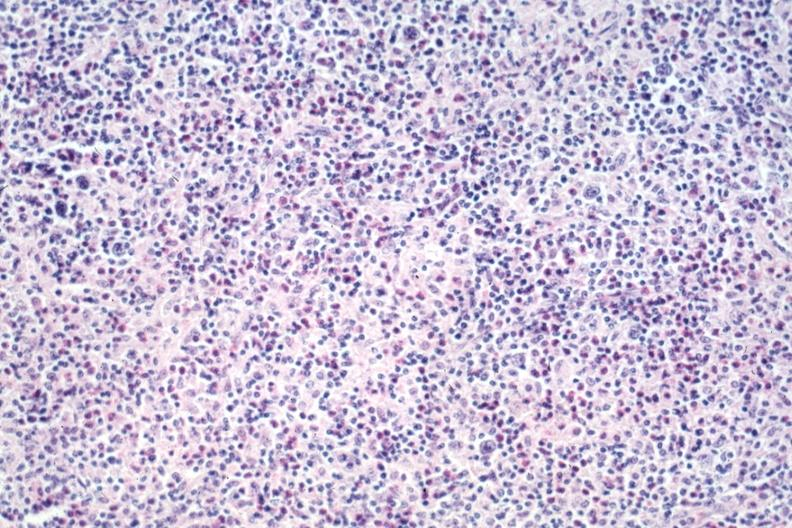does this image show typical lesion rich in eosinophils source?
Answer the question using a single word or phrase. Yes 